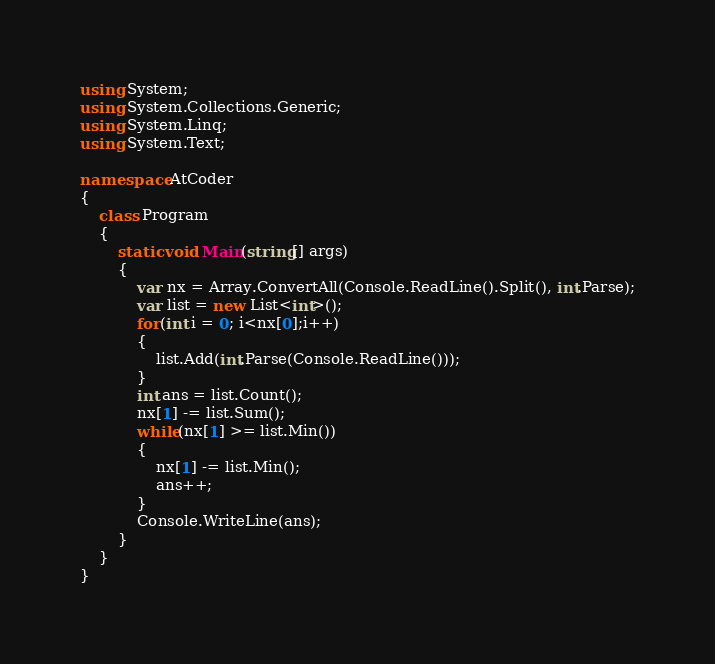<code> <loc_0><loc_0><loc_500><loc_500><_C#_>using System;
using System.Collections.Generic;
using System.Linq;
using System.Text;

namespace AtCoder
{
    class Program
    {
        static void Main(string[] args)
        {
            var nx = Array.ConvertAll(Console.ReadLine().Split(), int.Parse);
            var list = new List<int>();
            for(int i = 0; i<nx[0];i++)
            {
                list.Add(int.Parse(Console.ReadLine()));
            }
            int ans = list.Count();
            nx[1] -= list.Sum();
            while(nx[1] >= list.Min())
            {
                nx[1] -= list.Min();
                ans++;
            }
            Console.WriteLine(ans);
        }
    }
}</code> 